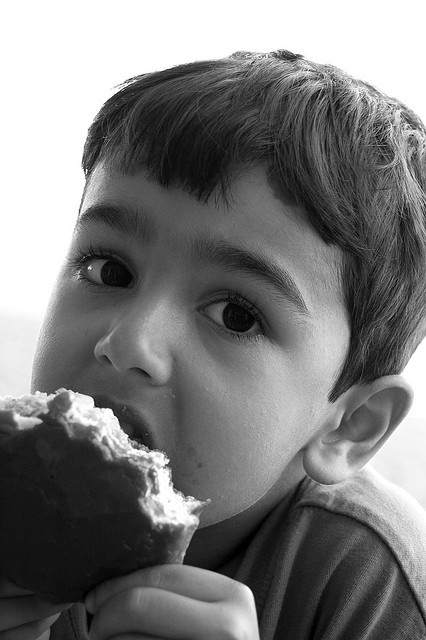Describe the objects in this image and their specific colors. I can see people in white, gray, black, darkgray, and lightgray tones and donut in white, black, lightgray, gray, and darkgray tones in this image. 